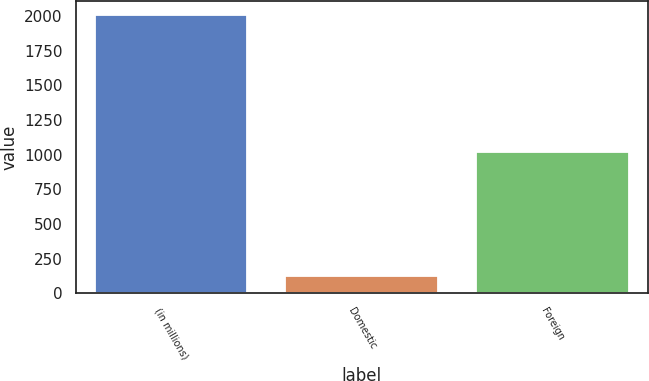<chart> <loc_0><loc_0><loc_500><loc_500><bar_chart><fcel>(in millions)<fcel>Domestic<fcel>Foreign<nl><fcel>2005<fcel>126<fcel>1017<nl></chart> 